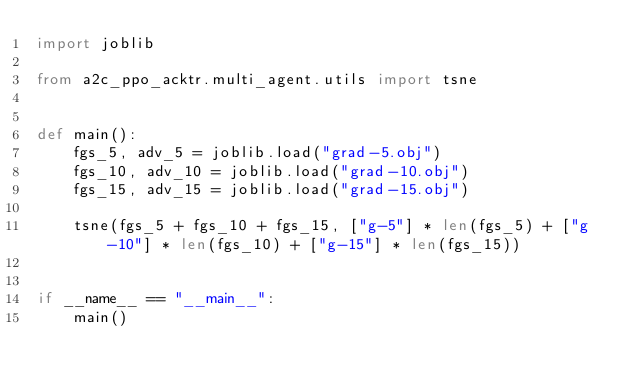<code> <loc_0><loc_0><loc_500><loc_500><_Python_>import joblib

from a2c_ppo_acktr.multi_agent.utils import tsne


def main():
    fgs_5, adv_5 = joblib.load("grad-5.obj")
    fgs_10, adv_10 = joblib.load("grad-10.obj")
    fgs_15, adv_15 = joblib.load("grad-15.obj")

    tsne(fgs_5 + fgs_10 + fgs_15, ["g-5"] * len(fgs_5) + ["g-10"] * len(fgs_10) + ["g-15"] * len(fgs_15))


if __name__ == "__main__":
    main()
</code> 